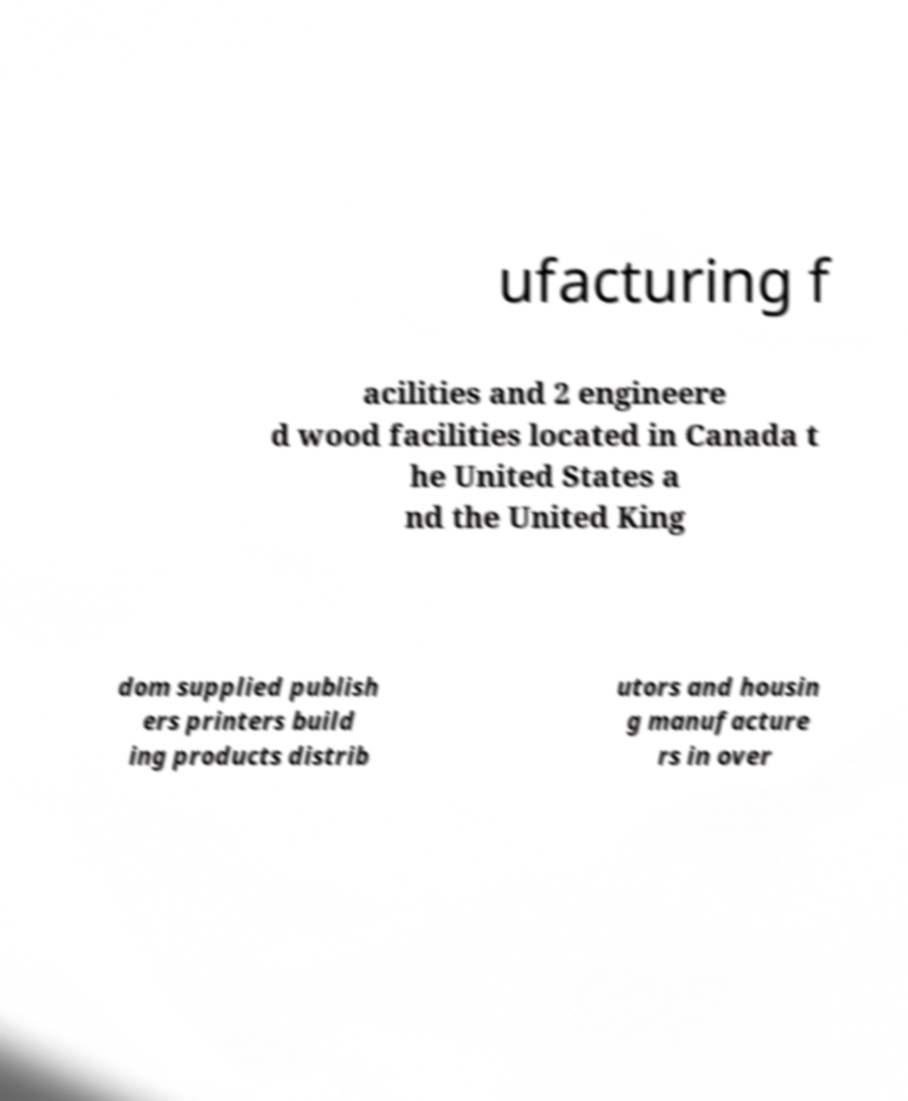Please read and relay the text visible in this image. What does it say? ufacturing f acilities and 2 engineere d wood facilities located in Canada t he United States a nd the United King dom supplied publish ers printers build ing products distrib utors and housin g manufacture rs in over 